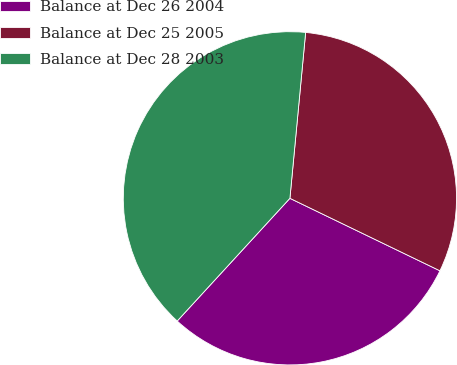Convert chart. <chart><loc_0><loc_0><loc_500><loc_500><pie_chart><fcel>Balance at Dec 26 2004<fcel>Balance at Dec 25 2005<fcel>Balance at Dec 28 2003<nl><fcel>29.66%<fcel>30.66%<fcel>39.68%<nl></chart> 